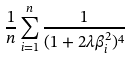<formula> <loc_0><loc_0><loc_500><loc_500>\frac { 1 } { n } \sum _ { i = 1 } ^ { n } \frac { 1 } { ( 1 + 2 \lambda \beta _ { i } ^ { 2 } ) ^ { 4 } }</formula> 